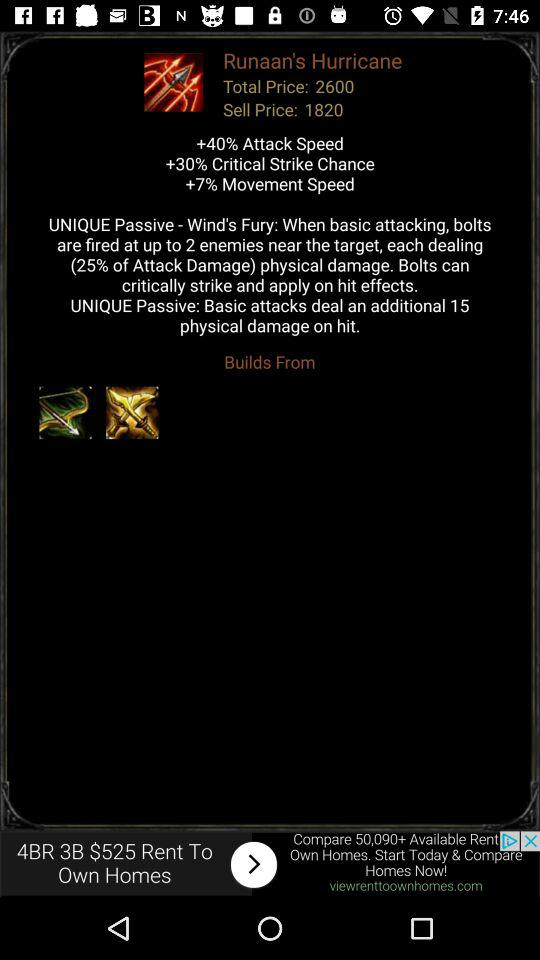What is the movement speed? The movement speed is 7%. 